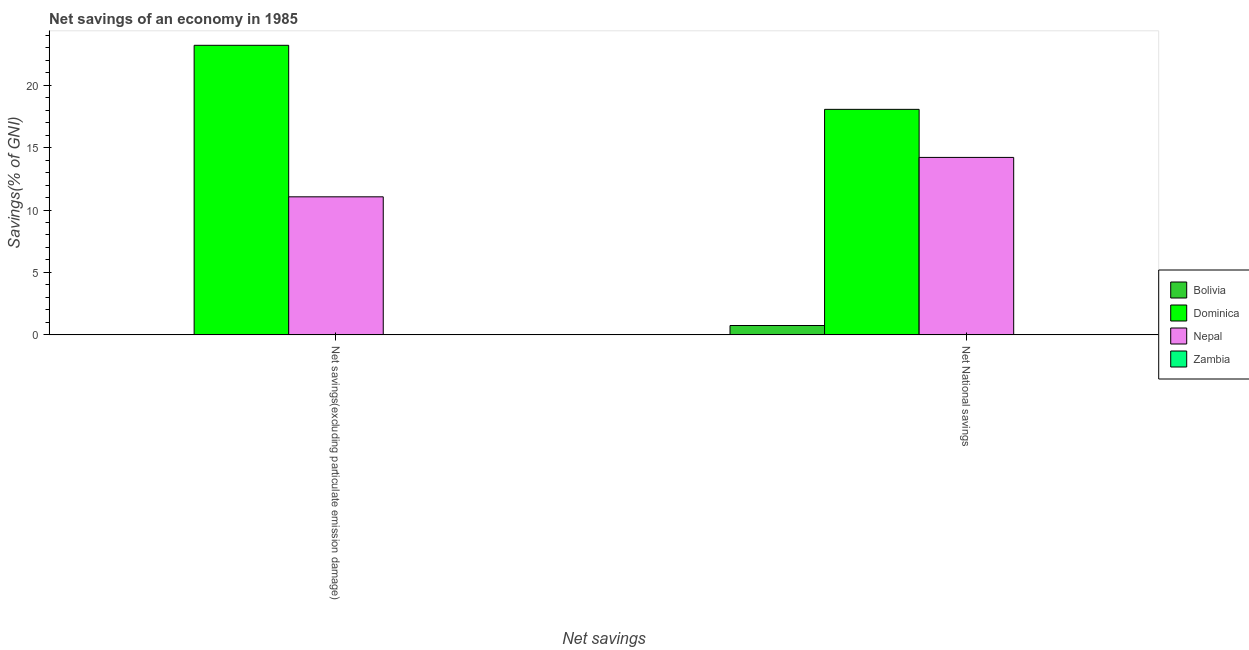How many groups of bars are there?
Offer a terse response. 2. How many bars are there on the 2nd tick from the left?
Provide a short and direct response. 3. How many bars are there on the 1st tick from the right?
Your response must be concise. 3. What is the label of the 1st group of bars from the left?
Provide a short and direct response. Net savings(excluding particulate emission damage). What is the net savings(excluding particulate emission damage) in Nepal?
Offer a terse response. 11.06. Across all countries, what is the maximum net national savings?
Your answer should be compact. 18.06. In which country was the net national savings maximum?
Offer a very short reply. Dominica. What is the total net savings(excluding particulate emission damage) in the graph?
Your answer should be very brief. 34.24. What is the difference between the net national savings in Bolivia and that in Nepal?
Your answer should be very brief. -13.46. What is the difference between the net national savings in Zambia and the net savings(excluding particulate emission damage) in Dominica?
Offer a very short reply. -23.19. What is the average net savings(excluding particulate emission damage) per country?
Make the answer very short. 8.56. What is the difference between the net national savings and net savings(excluding particulate emission damage) in Dominica?
Ensure brevity in your answer.  -5.13. In how many countries, is the net national savings greater than 13 %?
Provide a short and direct response. 2. What is the ratio of the net savings(excluding particulate emission damage) in Nepal to that in Dominica?
Your answer should be very brief. 0.48. In how many countries, is the net national savings greater than the average net national savings taken over all countries?
Offer a terse response. 2. Are all the bars in the graph horizontal?
Your response must be concise. No. How many countries are there in the graph?
Ensure brevity in your answer.  4. Are the values on the major ticks of Y-axis written in scientific E-notation?
Provide a succinct answer. No. Does the graph contain grids?
Your response must be concise. No. Where does the legend appear in the graph?
Ensure brevity in your answer.  Center right. What is the title of the graph?
Your response must be concise. Net savings of an economy in 1985. Does "Comoros" appear as one of the legend labels in the graph?
Keep it short and to the point. No. What is the label or title of the X-axis?
Offer a very short reply. Net savings. What is the label or title of the Y-axis?
Your answer should be compact. Savings(% of GNI). What is the Savings(% of GNI) of Dominica in Net savings(excluding particulate emission damage)?
Offer a terse response. 23.19. What is the Savings(% of GNI) in Nepal in Net savings(excluding particulate emission damage)?
Your answer should be very brief. 11.06. What is the Savings(% of GNI) of Bolivia in Net National savings?
Your response must be concise. 0.75. What is the Savings(% of GNI) of Dominica in Net National savings?
Offer a terse response. 18.06. What is the Savings(% of GNI) in Nepal in Net National savings?
Make the answer very short. 14.21. Across all Net savings, what is the maximum Savings(% of GNI) of Bolivia?
Your answer should be very brief. 0.75. Across all Net savings, what is the maximum Savings(% of GNI) in Dominica?
Offer a very short reply. 23.19. Across all Net savings, what is the maximum Savings(% of GNI) in Nepal?
Your answer should be compact. 14.21. Across all Net savings, what is the minimum Savings(% of GNI) of Dominica?
Provide a short and direct response. 18.06. Across all Net savings, what is the minimum Savings(% of GNI) of Nepal?
Your answer should be very brief. 11.06. What is the total Savings(% of GNI) in Bolivia in the graph?
Your response must be concise. 0.75. What is the total Savings(% of GNI) in Dominica in the graph?
Offer a terse response. 41.25. What is the total Savings(% of GNI) of Nepal in the graph?
Make the answer very short. 25.27. What is the total Savings(% of GNI) of Zambia in the graph?
Your answer should be very brief. 0. What is the difference between the Savings(% of GNI) in Dominica in Net savings(excluding particulate emission damage) and that in Net National savings?
Make the answer very short. 5.13. What is the difference between the Savings(% of GNI) of Nepal in Net savings(excluding particulate emission damage) and that in Net National savings?
Make the answer very short. -3.15. What is the difference between the Savings(% of GNI) in Dominica in Net savings(excluding particulate emission damage) and the Savings(% of GNI) in Nepal in Net National savings?
Keep it short and to the point. 8.98. What is the average Savings(% of GNI) of Bolivia per Net savings?
Give a very brief answer. 0.38. What is the average Savings(% of GNI) of Dominica per Net savings?
Give a very brief answer. 20.62. What is the average Savings(% of GNI) of Nepal per Net savings?
Ensure brevity in your answer.  12.63. What is the difference between the Savings(% of GNI) in Dominica and Savings(% of GNI) in Nepal in Net savings(excluding particulate emission damage)?
Provide a succinct answer. 12.13. What is the difference between the Savings(% of GNI) in Bolivia and Savings(% of GNI) in Dominica in Net National savings?
Offer a very short reply. -17.31. What is the difference between the Savings(% of GNI) of Bolivia and Savings(% of GNI) of Nepal in Net National savings?
Offer a terse response. -13.46. What is the difference between the Savings(% of GNI) of Dominica and Savings(% of GNI) of Nepal in Net National savings?
Provide a short and direct response. 3.85. What is the ratio of the Savings(% of GNI) of Dominica in Net savings(excluding particulate emission damage) to that in Net National savings?
Your response must be concise. 1.28. What is the ratio of the Savings(% of GNI) of Nepal in Net savings(excluding particulate emission damage) to that in Net National savings?
Provide a succinct answer. 0.78. What is the difference between the highest and the second highest Savings(% of GNI) of Dominica?
Offer a terse response. 5.13. What is the difference between the highest and the second highest Savings(% of GNI) of Nepal?
Make the answer very short. 3.15. What is the difference between the highest and the lowest Savings(% of GNI) of Bolivia?
Your response must be concise. 0.75. What is the difference between the highest and the lowest Savings(% of GNI) in Dominica?
Your response must be concise. 5.13. What is the difference between the highest and the lowest Savings(% of GNI) of Nepal?
Offer a terse response. 3.15. 